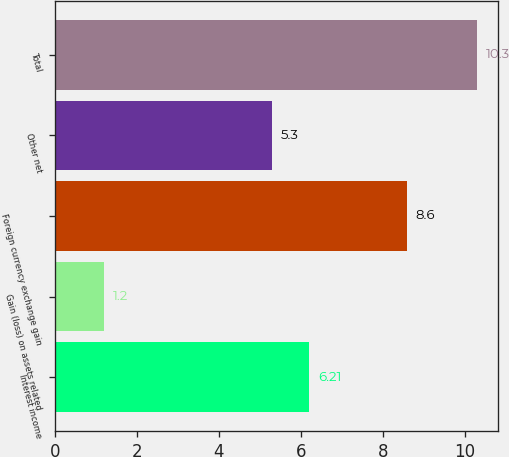Convert chart to OTSL. <chart><loc_0><loc_0><loc_500><loc_500><bar_chart><fcel>Interest income<fcel>Gain (loss) on assets related<fcel>Foreign currency exchange gain<fcel>Other net<fcel>Total<nl><fcel>6.21<fcel>1.2<fcel>8.6<fcel>5.3<fcel>10.3<nl></chart> 